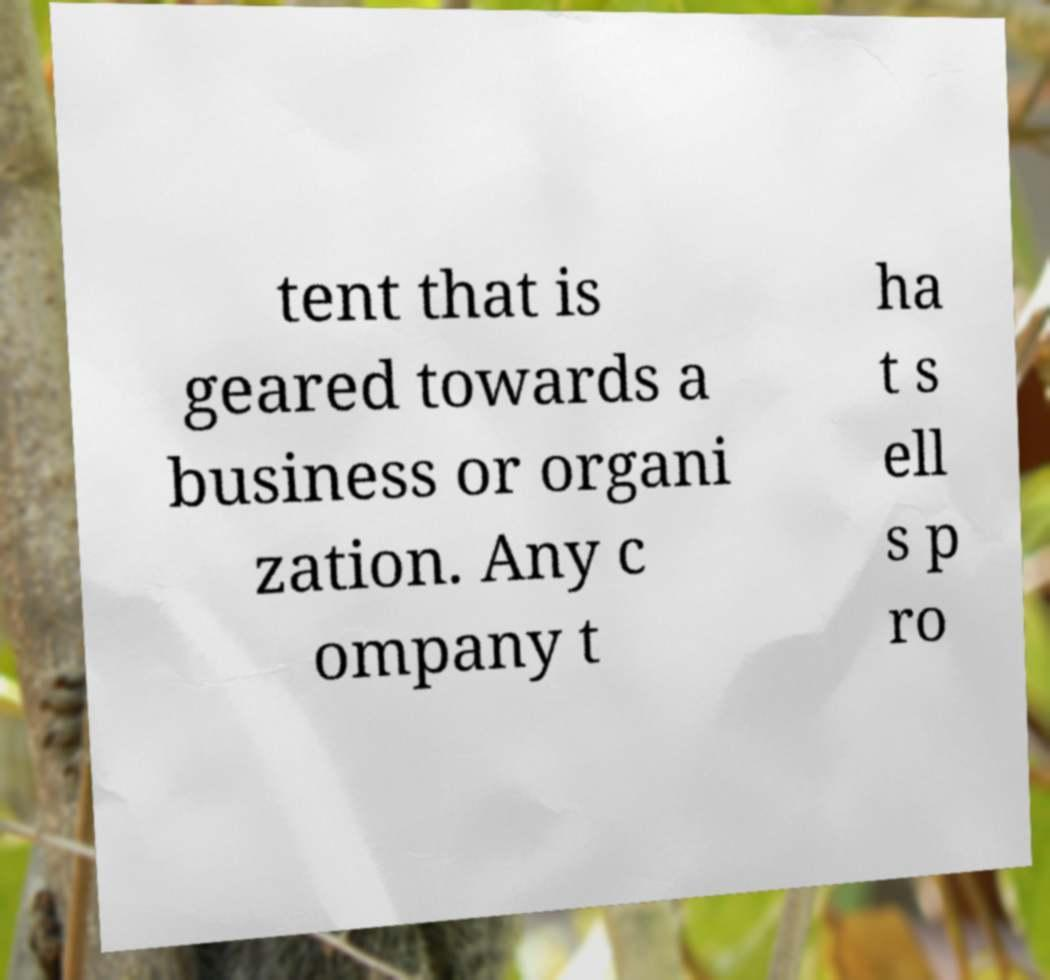For documentation purposes, I need the text within this image transcribed. Could you provide that? tent that is geared towards a business or organi zation. Any c ompany t ha t s ell s p ro 